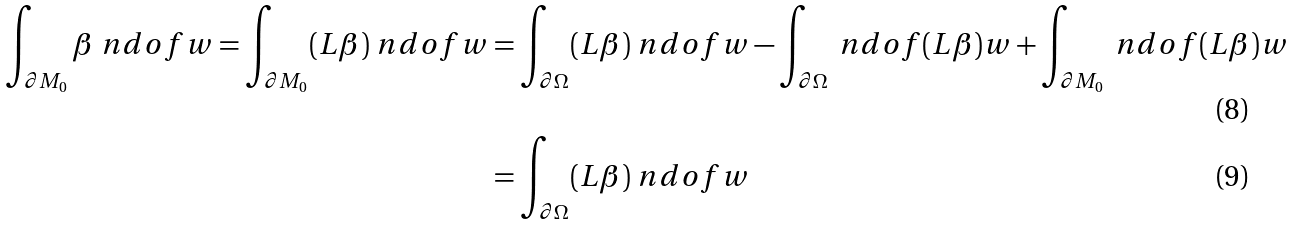<formula> <loc_0><loc_0><loc_500><loc_500>\int _ { \partial M _ { 0 } } \beta \ n d o f { w } = \int _ { \partial M _ { 0 } } ( L \beta ) \ n d o f { w } & = \int _ { \partial \Omega } ( L \beta ) \ n d o f { w } - \int _ { \partial \Omega } \ n d o f { ( L \beta ) } w + \int _ { \partial M _ { 0 } } \ n d o f { ( L \beta ) } w \\ & = \int _ { \partial \Omega } ( L \beta ) \ n d o f { w }</formula> 